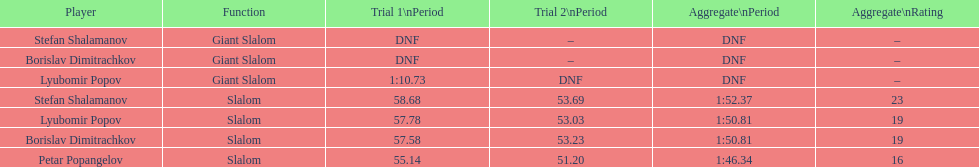What is the difference in time for petar popangelov in race 1and 2 3.94. 